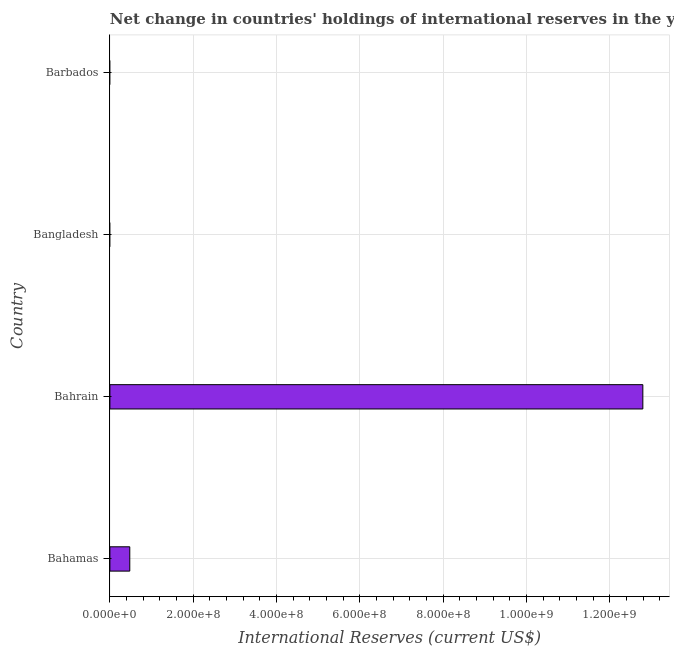Does the graph contain any zero values?
Give a very brief answer. Yes. Does the graph contain grids?
Ensure brevity in your answer.  Yes. What is the title of the graph?
Make the answer very short. Net change in countries' holdings of international reserves in the year 2010. What is the label or title of the X-axis?
Provide a short and direct response. International Reserves (current US$). What is the reserves and related items in Bahamas?
Make the answer very short. 4.78e+07. Across all countries, what is the maximum reserves and related items?
Your response must be concise. 1.28e+09. Across all countries, what is the minimum reserves and related items?
Provide a short and direct response. 0. In which country was the reserves and related items maximum?
Ensure brevity in your answer.  Bahrain. What is the sum of the reserves and related items?
Keep it short and to the point. 1.33e+09. What is the difference between the reserves and related items in Bahamas and Bahrain?
Ensure brevity in your answer.  -1.23e+09. What is the average reserves and related items per country?
Your answer should be very brief. 3.32e+08. What is the median reserves and related items?
Offer a very short reply. 2.39e+07. In how many countries, is the reserves and related items greater than 760000000 US$?
Give a very brief answer. 1. Is the reserves and related items in Bahamas less than that in Bahrain?
Offer a terse response. Yes. What is the difference between the highest and the lowest reserves and related items?
Your response must be concise. 1.28e+09. How many bars are there?
Your response must be concise. 2. Are all the bars in the graph horizontal?
Your response must be concise. Yes. How many countries are there in the graph?
Keep it short and to the point. 4. What is the difference between two consecutive major ticks on the X-axis?
Your answer should be very brief. 2.00e+08. Are the values on the major ticks of X-axis written in scientific E-notation?
Provide a short and direct response. Yes. What is the International Reserves (current US$) in Bahamas?
Provide a succinct answer. 4.78e+07. What is the International Reserves (current US$) of Bahrain?
Give a very brief answer. 1.28e+09. What is the International Reserves (current US$) of Bangladesh?
Your answer should be very brief. 0. What is the difference between the International Reserves (current US$) in Bahamas and Bahrain?
Provide a short and direct response. -1.23e+09. What is the ratio of the International Reserves (current US$) in Bahamas to that in Bahrain?
Provide a short and direct response. 0.04. 